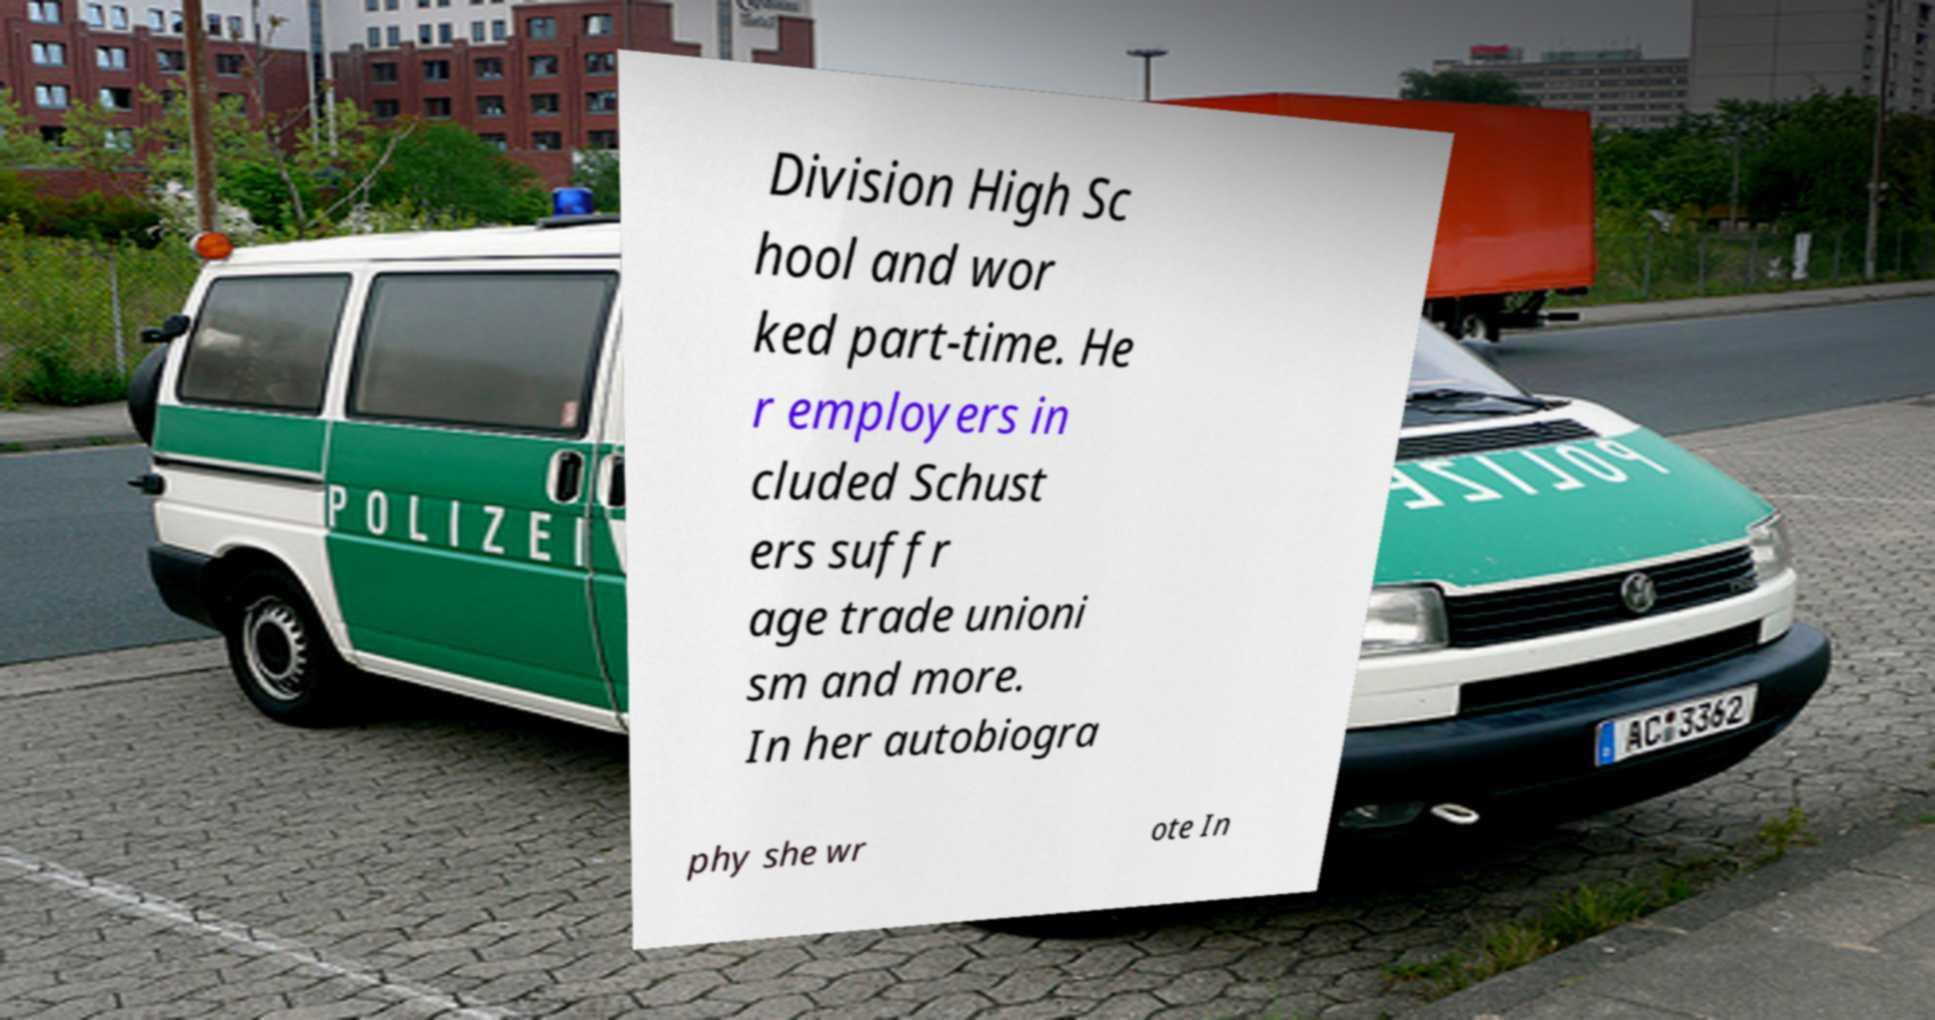I need the written content from this picture converted into text. Can you do that? Division High Sc hool and wor ked part-time. He r employers in cluded Schust ers suffr age trade unioni sm and more. In her autobiogra phy she wr ote In 